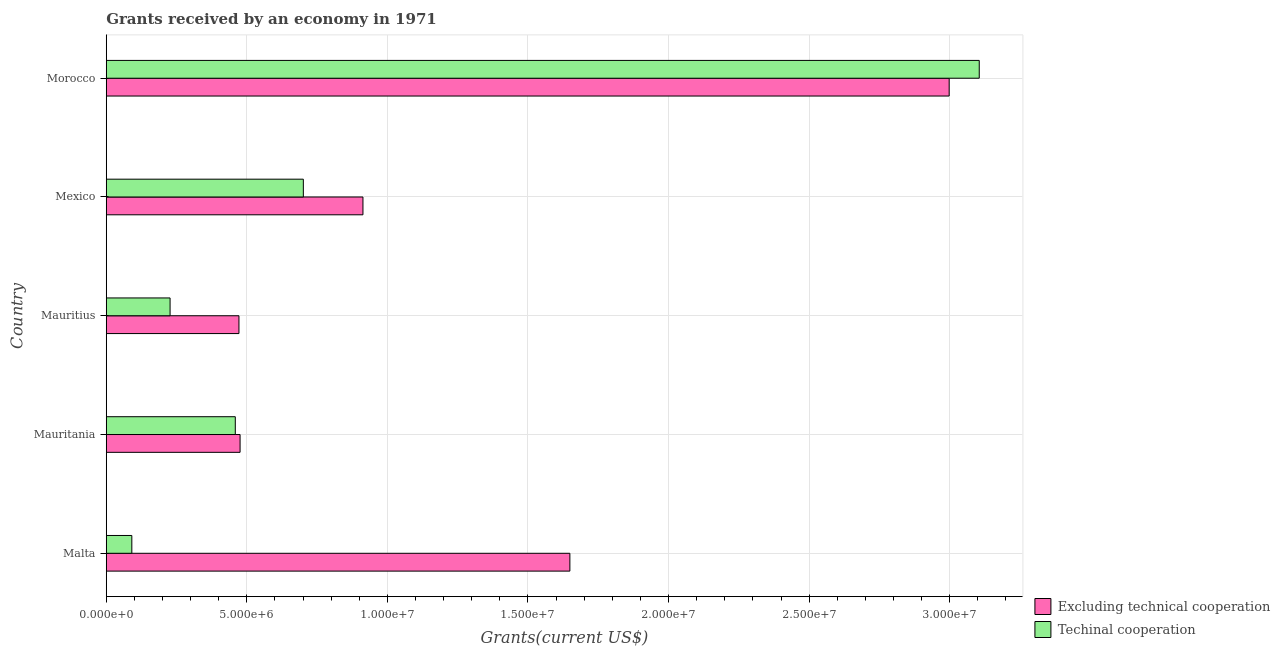How many different coloured bars are there?
Your answer should be very brief. 2. Are the number of bars per tick equal to the number of legend labels?
Ensure brevity in your answer.  Yes. What is the label of the 5th group of bars from the top?
Your response must be concise. Malta. In how many cases, is the number of bars for a given country not equal to the number of legend labels?
Your answer should be compact. 0. What is the amount of grants received(including technical cooperation) in Mexico?
Provide a succinct answer. 7.01e+06. Across all countries, what is the maximum amount of grants received(excluding technical cooperation)?
Offer a very short reply. 3.00e+07. Across all countries, what is the minimum amount of grants received(including technical cooperation)?
Your answer should be compact. 9.10e+05. In which country was the amount of grants received(excluding technical cooperation) maximum?
Provide a short and direct response. Morocco. In which country was the amount of grants received(including technical cooperation) minimum?
Your answer should be very brief. Malta. What is the total amount of grants received(including technical cooperation) in the graph?
Your answer should be very brief. 4.58e+07. What is the difference between the amount of grants received(including technical cooperation) in Mauritania and that in Mauritius?
Give a very brief answer. 2.32e+06. What is the difference between the amount of grants received(excluding technical cooperation) in Malta and the amount of grants received(including technical cooperation) in Mauritania?
Provide a succinct answer. 1.19e+07. What is the average amount of grants received(including technical cooperation) per country?
Ensure brevity in your answer.  9.17e+06. What is the difference between the amount of grants received(including technical cooperation) and amount of grants received(excluding technical cooperation) in Mauritania?
Offer a very short reply. -1.70e+05. In how many countries, is the amount of grants received(including technical cooperation) greater than 7000000 US$?
Provide a succinct answer. 2. What is the ratio of the amount of grants received(including technical cooperation) in Malta to that in Mauritius?
Provide a succinct answer. 0.4. What is the difference between the highest and the second highest amount of grants received(excluding technical cooperation)?
Your answer should be very brief. 1.35e+07. What is the difference between the highest and the lowest amount of grants received(including technical cooperation)?
Your response must be concise. 3.01e+07. In how many countries, is the amount of grants received(including technical cooperation) greater than the average amount of grants received(including technical cooperation) taken over all countries?
Make the answer very short. 1. What does the 2nd bar from the top in Morocco represents?
Ensure brevity in your answer.  Excluding technical cooperation. What does the 1st bar from the bottom in Malta represents?
Your answer should be very brief. Excluding technical cooperation. How many countries are there in the graph?
Keep it short and to the point. 5. What is the difference between two consecutive major ticks on the X-axis?
Your response must be concise. 5.00e+06. Are the values on the major ticks of X-axis written in scientific E-notation?
Keep it short and to the point. Yes. How are the legend labels stacked?
Make the answer very short. Vertical. What is the title of the graph?
Your response must be concise. Grants received by an economy in 1971. Does "Number of arrivals" appear as one of the legend labels in the graph?
Offer a very short reply. No. What is the label or title of the X-axis?
Your answer should be compact. Grants(current US$). What is the label or title of the Y-axis?
Provide a short and direct response. Country. What is the Grants(current US$) of Excluding technical cooperation in Malta?
Make the answer very short. 1.65e+07. What is the Grants(current US$) of Techinal cooperation in Malta?
Keep it short and to the point. 9.10e+05. What is the Grants(current US$) in Excluding technical cooperation in Mauritania?
Your response must be concise. 4.76e+06. What is the Grants(current US$) of Techinal cooperation in Mauritania?
Provide a succinct answer. 4.59e+06. What is the Grants(current US$) of Excluding technical cooperation in Mauritius?
Keep it short and to the point. 4.72e+06. What is the Grants(current US$) of Techinal cooperation in Mauritius?
Give a very brief answer. 2.27e+06. What is the Grants(current US$) of Excluding technical cooperation in Mexico?
Offer a very short reply. 9.13e+06. What is the Grants(current US$) in Techinal cooperation in Mexico?
Provide a short and direct response. 7.01e+06. What is the Grants(current US$) of Excluding technical cooperation in Morocco?
Your response must be concise. 3.00e+07. What is the Grants(current US$) in Techinal cooperation in Morocco?
Offer a very short reply. 3.10e+07. Across all countries, what is the maximum Grants(current US$) in Excluding technical cooperation?
Offer a very short reply. 3.00e+07. Across all countries, what is the maximum Grants(current US$) in Techinal cooperation?
Ensure brevity in your answer.  3.10e+07. Across all countries, what is the minimum Grants(current US$) of Excluding technical cooperation?
Your response must be concise. 4.72e+06. Across all countries, what is the minimum Grants(current US$) in Techinal cooperation?
Keep it short and to the point. 9.10e+05. What is the total Grants(current US$) in Excluding technical cooperation in the graph?
Ensure brevity in your answer.  6.51e+07. What is the total Grants(current US$) in Techinal cooperation in the graph?
Keep it short and to the point. 4.58e+07. What is the difference between the Grants(current US$) of Excluding technical cooperation in Malta and that in Mauritania?
Give a very brief answer. 1.17e+07. What is the difference between the Grants(current US$) in Techinal cooperation in Malta and that in Mauritania?
Your answer should be very brief. -3.68e+06. What is the difference between the Grants(current US$) in Excluding technical cooperation in Malta and that in Mauritius?
Your answer should be compact. 1.18e+07. What is the difference between the Grants(current US$) of Techinal cooperation in Malta and that in Mauritius?
Give a very brief answer. -1.36e+06. What is the difference between the Grants(current US$) of Excluding technical cooperation in Malta and that in Mexico?
Your response must be concise. 7.36e+06. What is the difference between the Grants(current US$) in Techinal cooperation in Malta and that in Mexico?
Provide a short and direct response. -6.10e+06. What is the difference between the Grants(current US$) in Excluding technical cooperation in Malta and that in Morocco?
Provide a succinct answer. -1.35e+07. What is the difference between the Grants(current US$) of Techinal cooperation in Malta and that in Morocco?
Make the answer very short. -3.01e+07. What is the difference between the Grants(current US$) of Excluding technical cooperation in Mauritania and that in Mauritius?
Your response must be concise. 4.00e+04. What is the difference between the Grants(current US$) in Techinal cooperation in Mauritania and that in Mauritius?
Make the answer very short. 2.32e+06. What is the difference between the Grants(current US$) of Excluding technical cooperation in Mauritania and that in Mexico?
Your response must be concise. -4.37e+06. What is the difference between the Grants(current US$) in Techinal cooperation in Mauritania and that in Mexico?
Provide a short and direct response. -2.42e+06. What is the difference between the Grants(current US$) of Excluding technical cooperation in Mauritania and that in Morocco?
Keep it short and to the point. -2.52e+07. What is the difference between the Grants(current US$) in Techinal cooperation in Mauritania and that in Morocco?
Your answer should be compact. -2.65e+07. What is the difference between the Grants(current US$) in Excluding technical cooperation in Mauritius and that in Mexico?
Your answer should be compact. -4.41e+06. What is the difference between the Grants(current US$) of Techinal cooperation in Mauritius and that in Mexico?
Keep it short and to the point. -4.74e+06. What is the difference between the Grants(current US$) in Excluding technical cooperation in Mauritius and that in Morocco?
Keep it short and to the point. -2.53e+07. What is the difference between the Grants(current US$) of Techinal cooperation in Mauritius and that in Morocco?
Provide a succinct answer. -2.88e+07. What is the difference between the Grants(current US$) of Excluding technical cooperation in Mexico and that in Morocco?
Offer a very short reply. -2.08e+07. What is the difference between the Grants(current US$) in Techinal cooperation in Mexico and that in Morocco?
Offer a very short reply. -2.40e+07. What is the difference between the Grants(current US$) of Excluding technical cooperation in Malta and the Grants(current US$) of Techinal cooperation in Mauritania?
Provide a succinct answer. 1.19e+07. What is the difference between the Grants(current US$) in Excluding technical cooperation in Malta and the Grants(current US$) in Techinal cooperation in Mauritius?
Make the answer very short. 1.42e+07. What is the difference between the Grants(current US$) in Excluding technical cooperation in Malta and the Grants(current US$) in Techinal cooperation in Mexico?
Your response must be concise. 9.48e+06. What is the difference between the Grants(current US$) of Excluding technical cooperation in Malta and the Grants(current US$) of Techinal cooperation in Morocco?
Make the answer very short. -1.46e+07. What is the difference between the Grants(current US$) of Excluding technical cooperation in Mauritania and the Grants(current US$) of Techinal cooperation in Mauritius?
Give a very brief answer. 2.49e+06. What is the difference between the Grants(current US$) of Excluding technical cooperation in Mauritania and the Grants(current US$) of Techinal cooperation in Mexico?
Keep it short and to the point. -2.25e+06. What is the difference between the Grants(current US$) of Excluding technical cooperation in Mauritania and the Grants(current US$) of Techinal cooperation in Morocco?
Offer a very short reply. -2.63e+07. What is the difference between the Grants(current US$) in Excluding technical cooperation in Mauritius and the Grants(current US$) in Techinal cooperation in Mexico?
Your response must be concise. -2.29e+06. What is the difference between the Grants(current US$) in Excluding technical cooperation in Mauritius and the Grants(current US$) in Techinal cooperation in Morocco?
Your answer should be compact. -2.63e+07. What is the difference between the Grants(current US$) in Excluding technical cooperation in Mexico and the Grants(current US$) in Techinal cooperation in Morocco?
Your answer should be very brief. -2.19e+07. What is the average Grants(current US$) of Excluding technical cooperation per country?
Offer a terse response. 1.30e+07. What is the average Grants(current US$) of Techinal cooperation per country?
Provide a succinct answer. 9.17e+06. What is the difference between the Grants(current US$) of Excluding technical cooperation and Grants(current US$) of Techinal cooperation in Malta?
Your response must be concise. 1.56e+07. What is the difference between the Grants(current US$) in Excluding technical cooperation and Grants(current US$) in Techinal cooperation in Mauritius?
Provide a short and direct response. 2.45e+06. What is the difference between the Grants(current US$) in Excluding technical cooperation and Grants(current US$) in Techinal cooperation in Mexico?
Keep it short and to the point. 2.12e+06. What is the difference between the Grants(current US$) in Excluding technical cooperation and Grants(current US$) in Techinal cooperation in Morocco?
Offer a terse response. -1.07e+06. What is the ratio of the Grants(current US$) in Excluding technical cooperation in Malta to that in Mauritania?
Your response must be concise. 3.46. What is the ratio of the Grants(current US$) of Techinal cooperation in Malta to that in Mauritania?
Offer a very short reply. 0.2. What is the ratio of the Grants(current US$) of Excluding technical cooperation in Malta to that in Mauritius?
Give a very brief answer. 3.49. What is the ratio of the Grants(current US$) of Techinal cooperation in Malta to that in Mauritius?
Ensure brevity in your answer.  0.4. What is the ratio of the Grants(current US$) of Excluding technical cooperation in Malta to that in Mexico?
Your answer should be compact. 1.81. What is the ratio of the Grants(current US$) of Techinal cooperation in Malta to that in Mexico?
Your answer should be compact. 0.13. What is the ratio of the Grants(current US$) of Excluding technical cooperation in Malta to that in Morocco?
Offer a terse response. 0.55. What is the ratio of the Grants(current US$) in Techinal cooperation in Malta to that in Morocco?
Provide a succinct answer. 0.03. What is the ratio of the Grants(current US$) in Excluding technical cooperation in Mauritania to that in Mauritius?
Keep it short and to the point. 1.01. What is the ratio of the Grants(current US$) in Techinal cooperation in Mauritania to that in Mauritius?
Provide a short and direct response. 2.02. What is the ratio of the Grants(current US$) in Excluding technical cooperation in Mauritania to that in Mexico?
Your answer should be compact. 0.52. What is the ratio of the Grants(current US$) in Techinal cooperation in Mauritania to that in Mexico?
Provide a succinct answer. 0.65. What is the ratio of the Grants(current US$) of Excluding technical cooperation in Mauritania to that in Morocco?
Ensure brevity in your answer.  0.16. What is the ratio of the Grants(current US$) in Techinal cooperation in Mauritania to that in Morocco?
Provide a short and direct response. 0.15. What is the ratio of the Grants(current US$) in Excluding technical cooperation in Mauritius to that in Mexico?
Offer a terse response. 0.52. What is the ratio of the Grants(current US$) of Techinal cooperation in Mauritius to that in Mexico?
Offer a terse response. 0.32. What is the ratio of the Grants(current US$) of Excluding technical cooperation in Mauritius to that in Morocco?
Offer a very short reply. 0.16. What is the ratio of the Grants(current US$) of Techinal cooperation in Mauritius to that in Morocco?
Keep it short and to the point. 0.07. What is the ratio of the Grants(current US$) in Excluding technical cooperation in Mexico to that in Morocco?
Offer a terse response. 0.3. What is the ratio of the Grants(current US$) in Techinal cooperation in Mexico to that in Morocco?
Ensure brevity in your answer.  0.23. What is the difference between the highest and the second highest Grants(current US$) of Excluding technical cooperation?
Offer a terse response. 1.35e+07. What is the difference between the highest and the second highest Grants(current US$) of Techinal cooperation?
Offer a very short reply. 2.40e+07. What is the difference between the highest and the lowest Grants(current US$) in Excluding technical cooperation?
Provide a succinct answer. 2.53e+07. What is the difference between the highest and the lowest Grants(current US$) of Techinal cooperation?
Ensure brevity in your answer.  3.01e+07. 